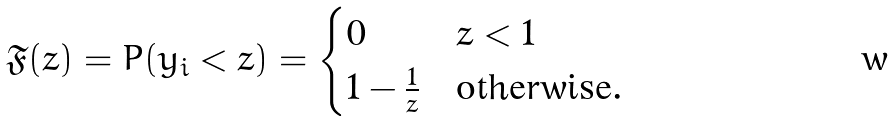<formula> <loc_0><loc_0><loc_500><loc_500>\mathfrak { F } ( z ) = P ( y _ { i } < z ) = \begin{cases} 0 & z < 1 \\ 1 - \frac { 1 } { z } & \text {otherwise} . \end{cases}</formula> 